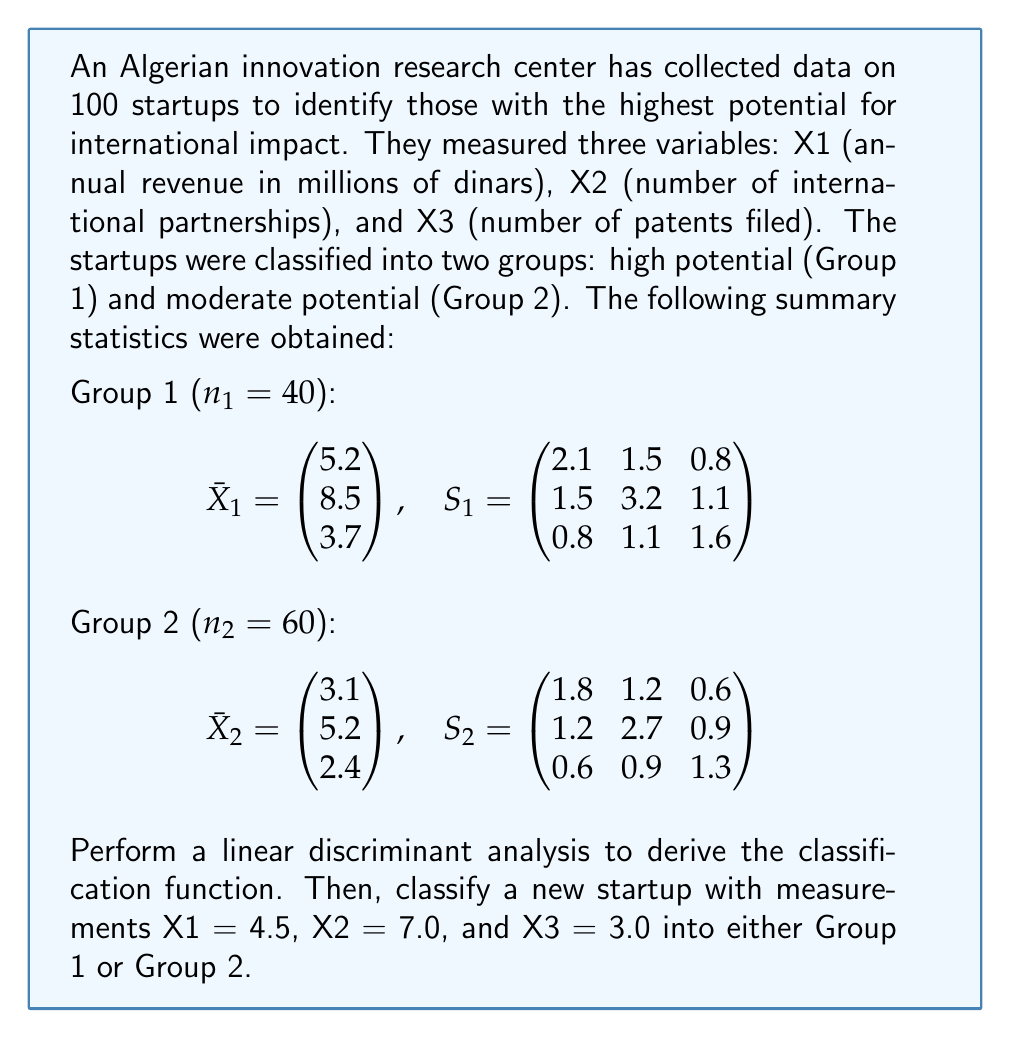Can you solve this math problem? To perform linear discriminant analysis and classify the new startup, we'll follow these steps:

1. Calculate the pooled covariance matrix $S_p$:
   $S_p = \frac{(n_1 - 1)S_1 + (n_2 - 1)S_2}{n_1 + n_2 - 2}$

2. Calculate $S_p^{-1}(\bar{X}_1 - \bar{X}_2)$

3. Determine the linear discriminant function:
   $L = (\bar{X}_1 - \bar{X}_2)'S_p^{-1}X - \frac{1}{2}(\bar{X}_1 - \bar{X}_2)'S_p^{-1}(\bar{X}_1 + \bar{X}_2)$

4. Calculate the cutoff value:
   $c = -\frac{1}{2}\ln(\frac{n_1}{n_2})$

5. Apply the classification rule:
   If $L \geq c$, classify as Group 1; otherwise, classify as Group 2.

Step 1: Calculate $S_p$
$S_p = \frac{39 \begin{pmatrix} 2.1 & 1.5 & 0.8 \\ 1.5 & 3.2 & 1.1 \\ 0.8 & 1.1 & 1.6 \end{pmatrix} + 59 \begin{pmatrix} 1.8 & 1.2 & 0.6 \\ 1.2 & 2.7 & 0.9 \\ 0.6 & 0.9 & 1.3 \end{pmatrix}}{98}$

$S_p = \begin{pmatrix} 1.92 & 1.32 & 0.68 \\ 1.32 & 2.89 & 0.98 \\ 0.68 & 0.98 & 1.42 \end{pmatrix}$

Step 2: Calculate $S_p^{-1}(\bar{X}_1 - \bar{X}_2)$
First, we need $S_p^{-1}$:
$S_p^{-1} = \begin{pmatrix} 0.6098 & -0.2432 & -0.1049 \\ -0.2432 & 0.4211 & -0.1877 \\ -0.1049 & -0.1877 & 0.7974 \end{pmatrix}$

Then, $\bar{X}_1 - \bar{X}_2 = \begin{pmatrix} 2.1 \\ 3.3 \\ 1.3 \end{pmatrix}$

$S_p^{-1}(\bar{X}_1 - \bar{X}_2) = \begin{pmatrix} 0.6098 & -0.2432 & -0.1049 \\ -0.2432 & 0.4211 & -0.1877 \\ -0.1049 & -0.1877 & 0.7974 \end{pmatrix} \begin{pmatrix} 2.1 \\ 3.3 \\ 1.3 \end{pmatrix} = \begin{pmatrix} 0.5906 \\ 0.7845 \\ 0.5235 \end{pmatrix}$

Step 3: Determine the linear discriminant function
$L = 0.5906X_1 + 0.7845X_2 + 0.5235X_3 - 8.0723$

Step 4: Calculate the cutoff value
$c = -\frac{1}{2}\ln(\frac{40}{60}) = 0.2027$

Step 5: Apply the classification rule
For the new startup (4.5, 7.0, 3.0):
$L = 0.5906(4.5) + 0.7845(7.0) + 0.5235(3.0) - 8.0723 = 0.9912$

Since $0.9912 > 0.2027$, we classify the new startup as Group 1 (high potential).
Answer: The new startup with measurements X1 = 4.5, X2 = 7.0, and X3 = 3.0 is classified as Group 1 (high potential) based on the linear discriminant analysis. 